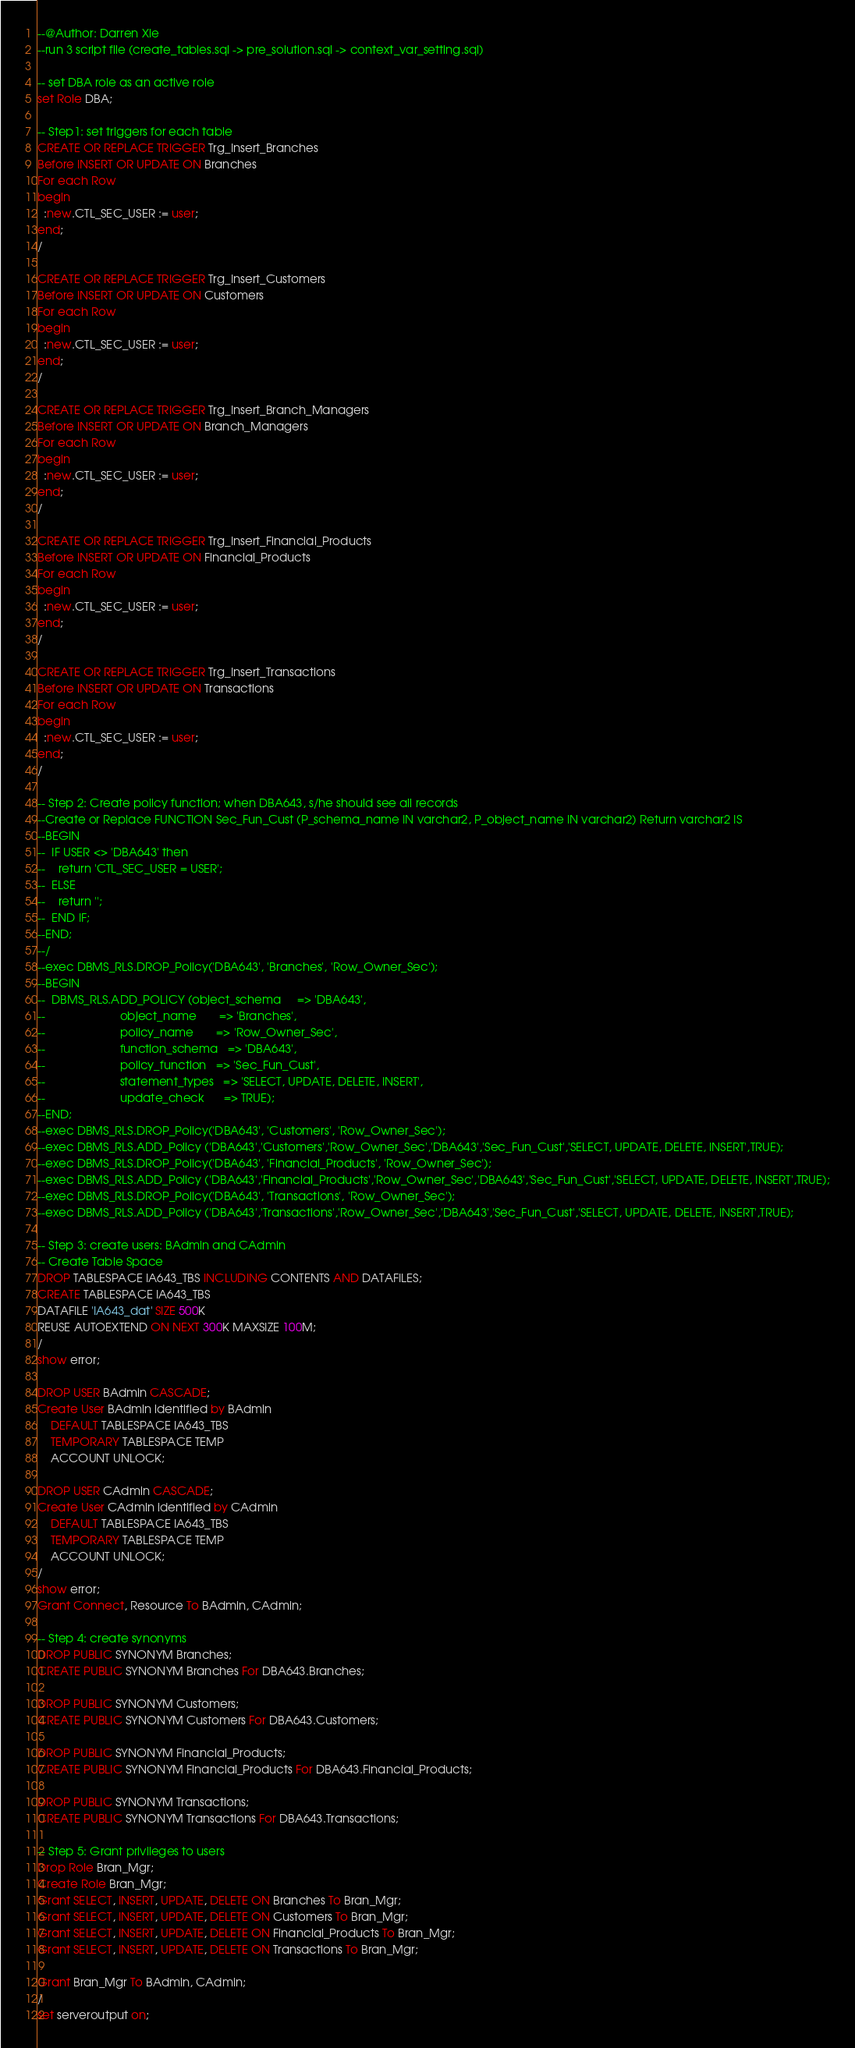<code> <loc_0><loc_0><loc_500><loc_500><_SQL_>--@Author: Darren Xie
--run 3 script file (create_tables.sql -> pre_solution.sql -> context_var_setting.sql)

-- set DBA role as an active role
set Role DBA;

-- Step1: set triggers for each table
CREATE OR REPLACE TRIGGER Trg_Insert_Branches
Before INSERT OR UPDATE ON Branches
For each Row
begin
  :new.CTL_SEC_USER := user;
end;
/

CREATE OR REPLACE TRIGGER Trg_Insert_Customers
Before INSERT OR UPDATE ON Customers
For each Row
begin
  :new.CTL_SEC_USER := user;
end;
/

CREATE OR REPLACE TRIGGER Trg_Insert_Branch_Managers
Before INSERT OR UPDATE ON Branch_Managers
For each Row
begin
  :new.CTL_SEC_USER := user;
end;
/

CREATE OR REPLACE TRIGGER Trg_Insert_Financial_Products
Before INSERT OR UPDATE ON Financial_Products
For each Row
begin
  :new.CTL_SEC_USER := user;
end;
/

CREATE OR REPLACE TRIGGER Trg_Insert_Transactions
Before INSERT OR UPDATE ON Transactions
For each Row
begin
  :new.CTL_SEC_USER := user;
end;
/

-- Step 2: Create policy function; when DBA643, s/he should see all records
--Create or Replace FUNCTION Sec_Fun_Cust (P_schema_name IN varchar2, P_object_name IN varchar2) Return varchar2 IS
--BEGIN
--  IF USER <> 'DBA643' then
--    return 'CTL_SEC_USER = USER';
--  ELSE
--    return '';
--  END IF; 
--END;
--/
--exec DBMS_RLS.DROP_Policy('DBA643', 'Branches', 'Row_Owner_Sec');
--BEGIN
--  DBMS_RLS.ADD_POLICY (object_schema     => 'DBA643',
--                       object_name       => 'Branches',
--                       policy_name       => 'Row_Owner_Sec',
--                       function_schema   => 'DBA643',
--                       policy_function   => 'Sec_Fun_Cust',
--                       statement_types   => 'SELECT, UPDATE, DELETE, INSERT',
--                       update_check      => TRUE);
--END;
--exec DBMS_RLS.DROP_Policy('DBA643', 'Customers', 'Row_Owner_Sec');
--exec DBMS_RLS.ADD_Policy ('DBA643','Customers','Row_Owner_Sec','DBA643','Sec_Fun_Cust','SELECT, UPDATE, DELETE, INSERT',TRUE);
--exec DBMS_RLS.DROP_Policy('DBA643', 'Financial_Products', 'Row_Owner_Sec');
--exec DBMS_RLS.ADD_Policy ('DBA643','Financial_Products','Row_Owner_Sec','DBA643','Sec_Fun_Cust','SELECT, UPDATE, DELETE, INSERT',TRUE);
--exec DBMS_RLS.DROP_Policy('DBA643', 'Transactions', 'Row_Owner_Sec');
--exec DBMS_RLS.ADD_Policy ('DBA643','Transactions','Row_Owner_Sec','DBA643','Sec_Fun_Cust','SELECT, UPDATE, DELETE, INSERT',TRUE);

-- Step 3: create users: BAdmin and CAdmin
-- Create Table Space
DROP TABLESPACE IA643_TBS INCLUDING CONTENTS AND DATAFILES;
CREATE TABLESPACE IA643_TBS
DATAFILE 'IA643_dat' SIZE 500K
REUSE AUTOEXTEND ON NEXT 300K MAXSIZE 100M;
/
show error;

DROP USER BAdmin CASCADE;
Create User BAdmin identified by BAdmin
    DEFAULT TABLESPACE IA643_TBS
    TEMPORARY TABLESPACE TEMP
    ACCOUNT UNLOCK;
    
DROP USER CAdmin CASCADE;
Create User CAdmin identified by CAdmin
    DEFAULT TABLESPACE IA643_TBS
    TEMPORARY TABLESPACE TEMP
    ACCOUNT UNLOCK;
/
show error;
Grant Connect, Resource To BAdmin, CAdmin;

-- Step 4: create synonyms
DROP PUBLIC SYNONYM Branches;
CREATE PUBLIC SYNONYM Branches For DBA643.Branches;

DROP PUBLIC SYNONYM Customers;
CREATE PUBLIC SYNONYM Customers For DBA643.Customers;

DROP PUBLIC SYNONYM Financial_Products;
CREATE PUBLIC SYNONYM Financial_Products For DBA643.Financial_Products;

DROP PUBLIC SYNONYM Transactions;
CREATE PUBLIC SYNONYM Transactions For DBA643.Transactions;

-- Step 5: Grant privileges to users
Drop Role Bran_Mgr;
Create Role Bran_Mgr;
Grant SELECT, INSERT, UPDATE, DELETE ON Branches To Bran_Mgr;
Grant SELECT, INSERT, UPDATE, DELETE ON Customers To Bran_Mgr;
Grant SELECT, INSERT, UPDATE, DELETE ON Financial_Products To Bran_Mgr;
Grant SELECT, INSERT, UPDATE, DELETE ON Transactions To Bran_Mgr;

Grant Bran_Mgr To BAdmin, CAdmin;
/
set serveroutput on;</code> 